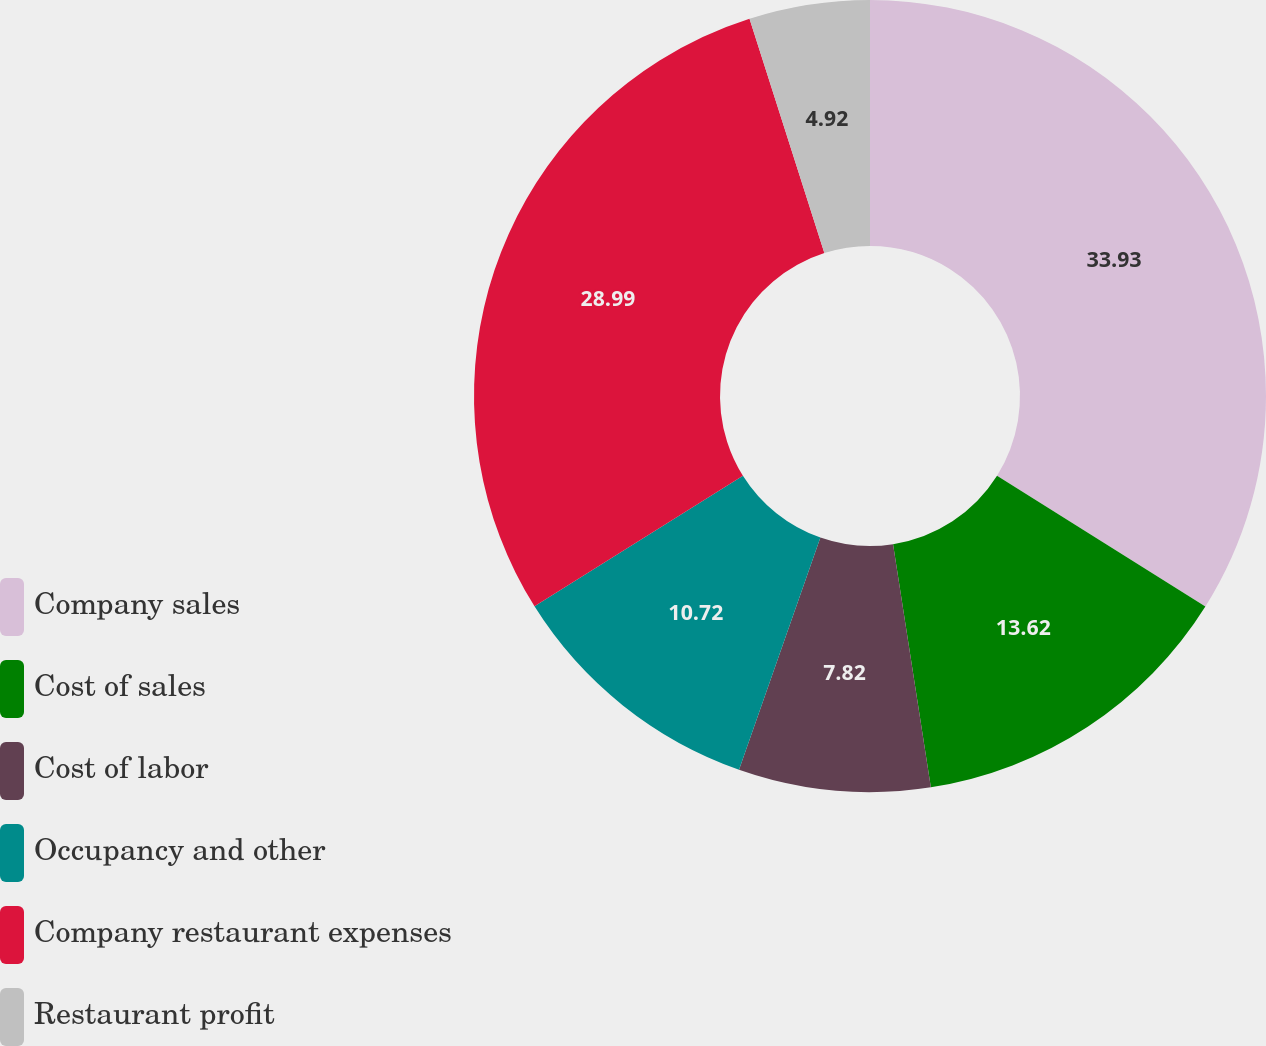<chart> <loc_0><loc_0><loc_500><loc_500><pie_chart><fcel>Company sales<fcel>Cost of sales<fcel>Cost of labor<fcel>Occupancy and other<fcel>Company restaurant expenses<fcel>Restaurant profit<nl><fcel>33.92%<fcel>13.62%<fcel>7.82%<fcel>10.72%<fcel>28.99%<fcel>4.92%<nl></chart> 